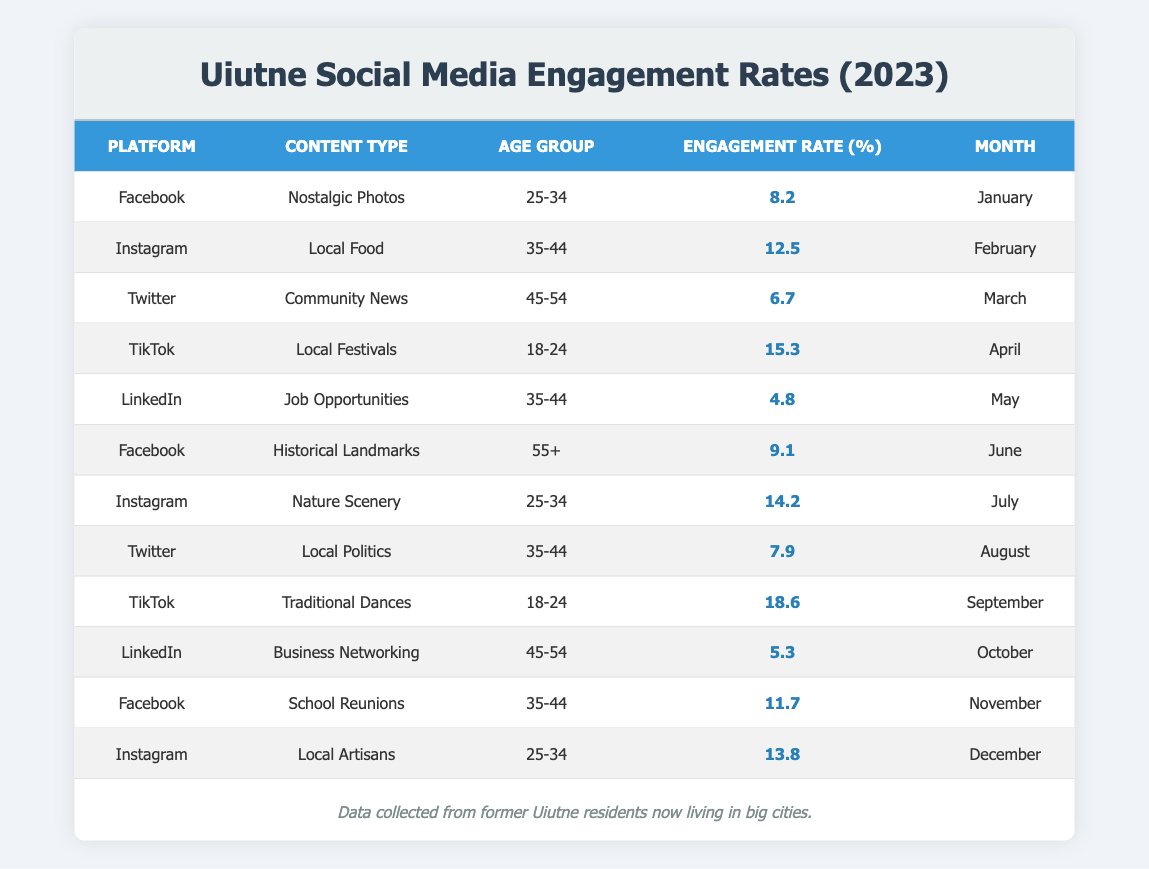What is the engagement rate for "Nostalgic Photos" on Facebook in January 2023? The table shows that the engagement rate for "Nostalgic Photos" on Facebook is listed in January 2023 as 8.2%.
Answer: 8.2% Which content type on TikTok had the highest engagement rate in 2023? Reviewing the TikTok entries, "Traditional Dances" in September 2023 has the highest engagement rate at 18.6%.
Answer: Traditional Dances What was the average engagement rate for the content types targeted at the 35-44 age group? The engagement rates for the 35-44 age group are 12.5, 4.8, 7.9, and 11.7. Adding these together gives 36.9. Dividing by the number of entries (4) results in an average of 9.225%.
Answer: 9.225% Is the engagement rate for "Historical Landmarks" on Facebook greater than 10%? The engagement rate for "Historical Landmarks" on Facebook is 9.1%, which is less than 10%.
Answer: No How do the engagement rates for Instagram content types aimed at the 25-34 age group compare overall? The engagement rates for the 25-34 age group on Instagram are 14.2 for "Nature Scenery" and 13.8 for "Local Artisans." This shows that both are above 13% but the former has a higher engagement rate.
Answer: 14.2 > 13.8 What is the total engagement rate for content types across all platforms in June and July 2023? In June 2023, the engagement rate is 9.1 (Facebook) and in July 2023 is 14.2 (Instagram). Summing these gives 23.3.
Answer: 23.3 Which platform had the lowest engagement rate among the content types for the 45-54 age group? The engagement rates for the 45-54 age group are 6.7 (Twitter in March) and 5.3 (LinkedIn in October). The lowest is 5.3 from LinkedIn.
Answer: LinkedIn Are more engagement rates for content related to festivals or local politics higher? Comparing TikTok's "Local Festivals" engagement rate of 15.3 in April versus Twitter's "Local Politics" engagement rate of 7.9 in August shows that Local Festivals has a higher engagement rate.
Answer: Yes What is the total engagement rate of all content types on LinkedIn throughout 2023? The engagement rates for LinkedIn are 4.8 (May) and 5.3 (October). Summing these gives 10.1 as the total engagement rate.
Answer: 10.1 